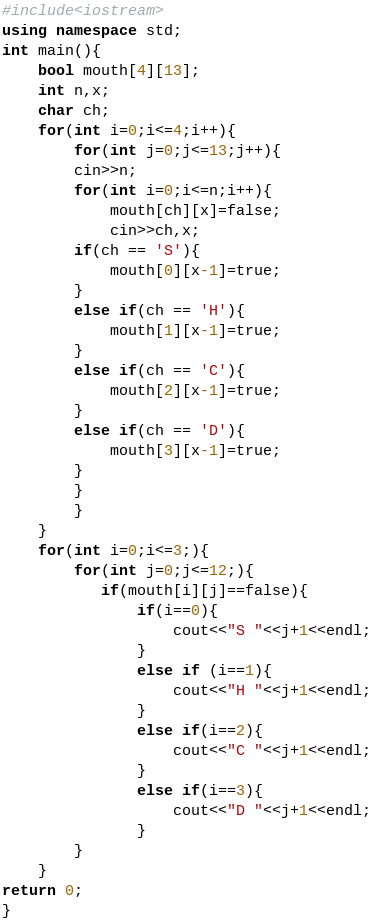<code> <loc_0><loc_0><loc_500><loc_500><_C++_>#include<iostream>
using namespace std;
int main(){
    bool mouth[4][13];
    int n,x;
    char ch;
    for(int i=0;i<=4;i++){
        for(int j=0;j<=13;j++){
        cin>>n;
        for(int i=0;i<=n;i++){
            mouth[ch][x]=false;
            cin>>ch,x;
        if(ch == 'S'){
            mouth[0][x-1]=true;
        }
        else if(ch == 'H'){
            mouth[1][x-1]=true;
        }
        else if(ch == 'C'){
            mouth[2][x-1]=true;
        }
        else if(ch == 'D'){
            mouth[3][x-1]=true;
        }
        }
        }
    }
    for(int i=0;i<=3;){
        for(int j=0;j<=12;){
           if(mouth[i][j]==false){
               if(i==0){
                   cout<<"S "<<j+1<<endl;
               }
               else if (i==1){
                   cout<<"H "<<j+1<<endl;
               }
               else if(i==2){
                   cout<<"C "<<j+1<<endl;
               }
               else if(i==3){
                   cout<<"D "<<j+1<<endl;
               }
        }
    }
return 0;
}
</code> 